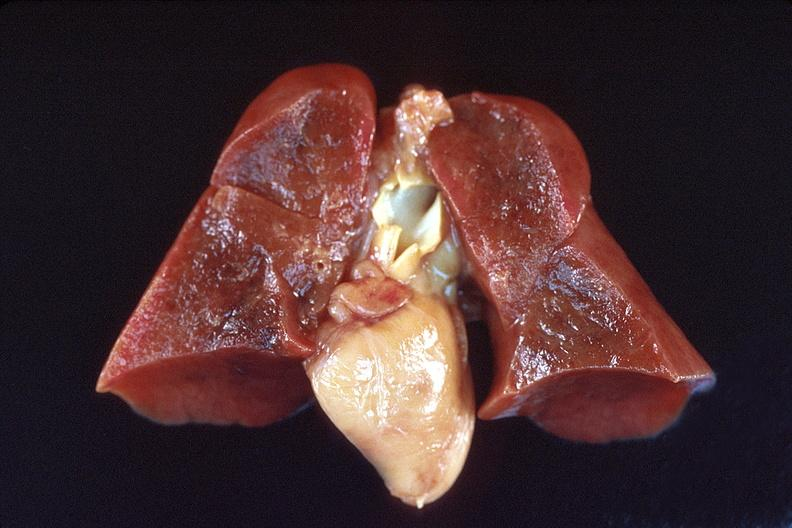s lateral view present?
Answer the question using a single word or phrase. No 